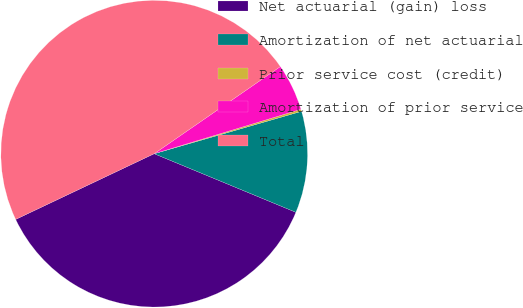<chart> <loc_0><loc_0><loc_500><loc_500><pie_chart><fcel>Net actuarial (gain) loss<fcel>Amortization of net actuarial<fcel>Prior service cost (credit)<fcel>Amortization of prior service<fcel>Total<nl><fcel>36.71%<fcel>10.7%<fcel>0.22%<fcel>4.94%<fcel>47.43%<nl></chart> 